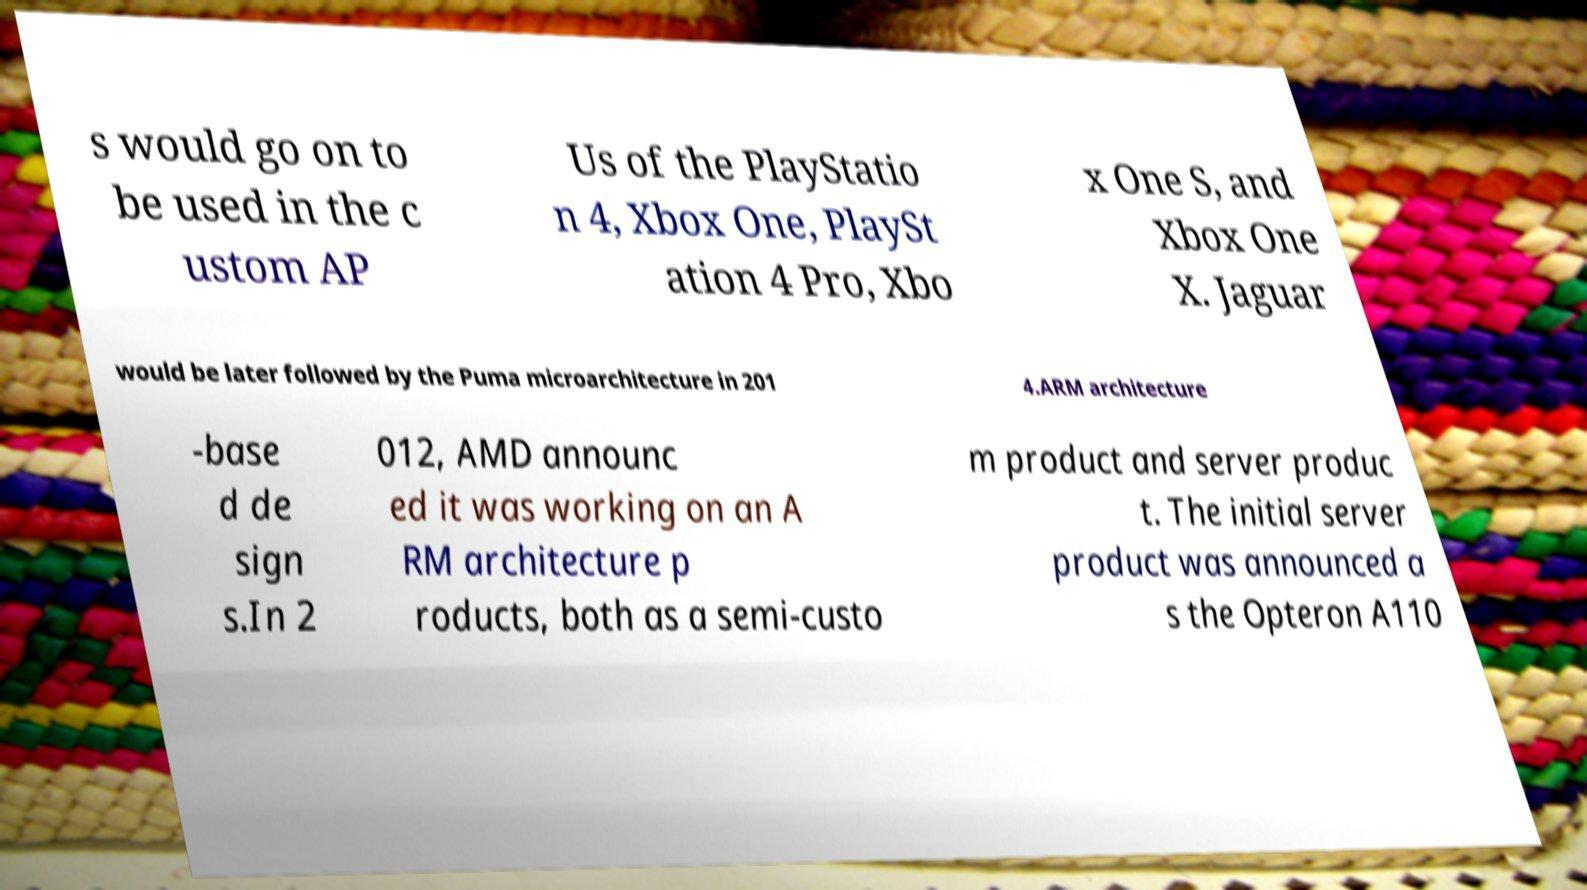What messages or text are displayed in this image? I need them in a readable, typed format. s would go on to be used in the c ustom AP Us of the PlayStatio n 4, Xbox One, PlaySt ation 4 Pro, Xbo x One S, and Xbox One X. Jaguar would be later followed by the Puma microarchitecture in 201 4.ARM architecture -base d de sign s.In 2 012, AMD announc ed it was working on an A RM architecture p roducts, both as a semi-custo m product and server produc t. The initial server product was announced a s the Opteron A110 